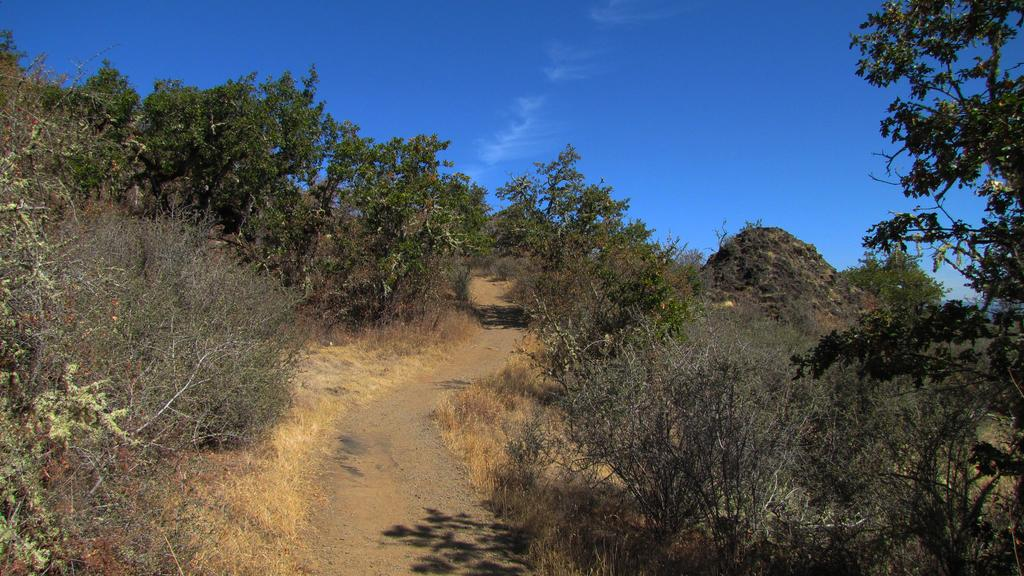What types of vegetation can be seen on both sides of the image? There are plants and trees on both sides of the image. What is visible at the top of the image? The sky is visible at the top of the image. What type of alarm is ringing in the image? There is no alarm present in the image. What color is the vest worn by the tree on the right side of the image? There are no vests or trees wearing clothing in the image; it features plants and trees without any additional accessories. 